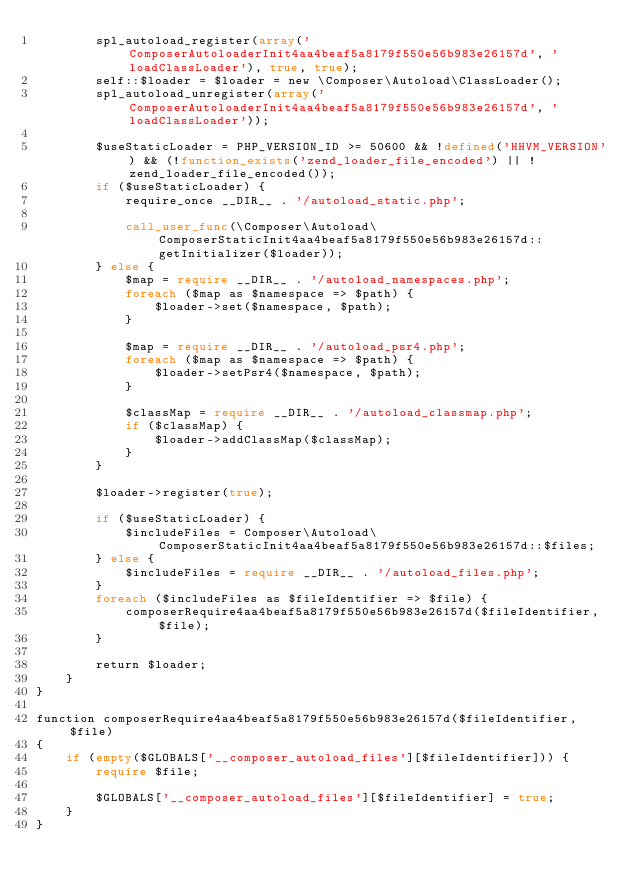Convert code to text. <code><loc_0><loc_0><loc_500><loc_500><_PHP_>        spl_autoload_register(array('ComposerAutoloaderInit4aa4beaf5a8179f550e56b983e26157d', 'loadClassLoader'), true, true);
        self::$loader = $loader = new \Composer\Autoload\ClassLoader();
        spl_autoload_unregister(array('ComposerAutoloaderInit4aa4beaf5a8179f550e56b983e26157d', 'loadClassLoader'));

        $useStaticLoader = PHP_VERSION_ID >= 50600 && !defined('HHVM_VERSION') && (!function_exists('zend_loader_file_encoded') || !zend_loader_file_encoded());
        if ($useStaticLoader) {
            require_once __DIR__ . '/autoload_static.php';

            call_user_func(\Composer\Autoload\ComposerStaticInit4aa4beaf5a8179f550e56b983e26157d::getInitializer($loader));
        } else {
            $map = require __DIR__ . '/autoload_namespaces.php';
            foreach ($map as $namespace => $path) {
                $loader->set($namespace, $path);
            }

            $map = require __DIR__ . '/autoload_psr4.php';
            foreach ($map as $namespace => $path) {
                $loader->setPsr4($namespace, $path);
            }

            $classMap = require __DIR__ . '/autoload_classmap.php';
            if ($classMap) {
                $loader->addClassMap($classMap);
            }
        }

        $loader->register(true);

        if ($useStaticLoader) {
            $includeFiles = Composer\Autoload\ComposerStaticInit4aa4beaf5a8179f550e56b983e26157d::$files;
        } else {
            $includeFiles = require __DIR__ . '/autoload_files.php';
        }
        foreach ($includeFiles as $fileIdentifier => $file) {
            composerRequire4aa4beaf5a8179f550e56b983e26157d($fileIdentifier, $file);
        }

        return $loader;
    }
}

function composerRequire4aa4beaf5a8179f550e56b983e26157d($fileIdentifier, $file)
{
    if (empty($GLOBALS['__composer_autoload_files'][$fileIdentifier])) {
        require $file;

        $GLOBALS['__composer_autoload_files'][$fileIdentifier] = true;
    }
}
</code> 